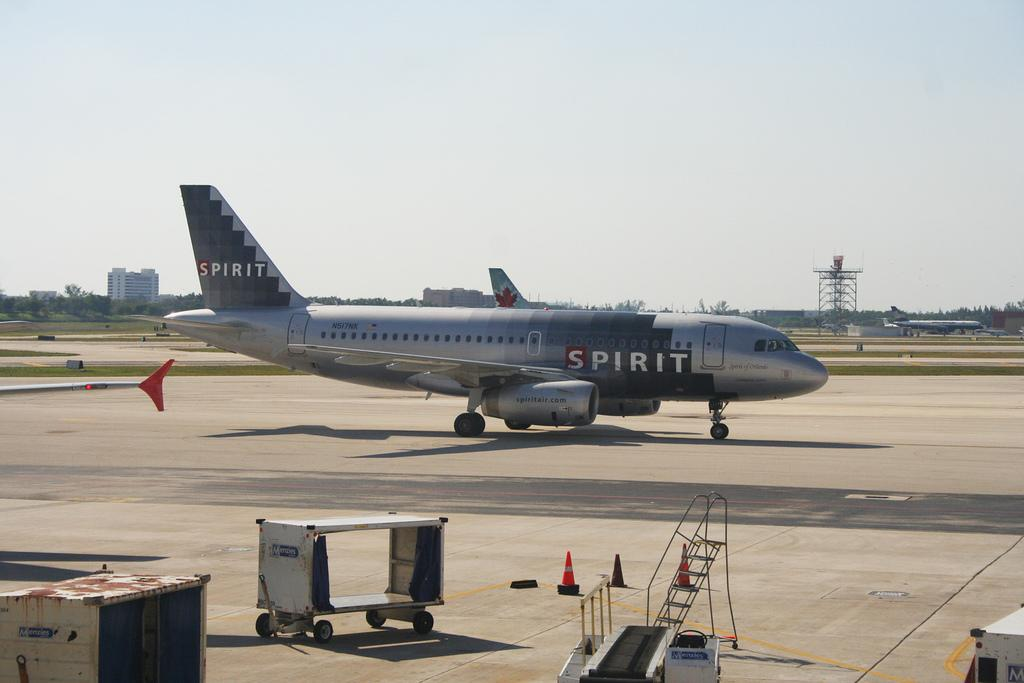<image>
Summarize the visual content of the image. A plan that has Spirit painted on it in two locations. 